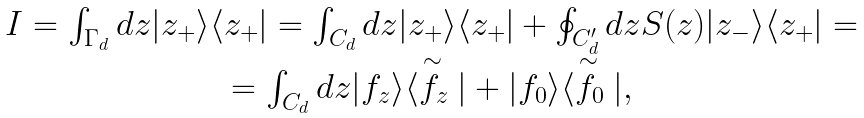Convert formula to latex. <formula><loc_0><loc_0><loc_500><loc_500>\begin{array} { c } I = \int _ { \Gamma _ { d } } d z | z _ { + } \rangle \langle z _ { + } | = \int _ { C _ { d } } d z | z _ { + } \rangle \langle z _ { + } | + \oint _ { C _ { d } ^ { \prime } } d z S ( z ) | z _ { - } \rangle \langle z _ { + } | = \\ = \int _ { C _ { d } } d z | f _ { z } \rangle \langle \stackrel { \sim } { f _ { z } } | + | f _ { 0 } \rangle \langle \stackrel { \sim } { f _ { 0 } } | , \end{array}</formula> 